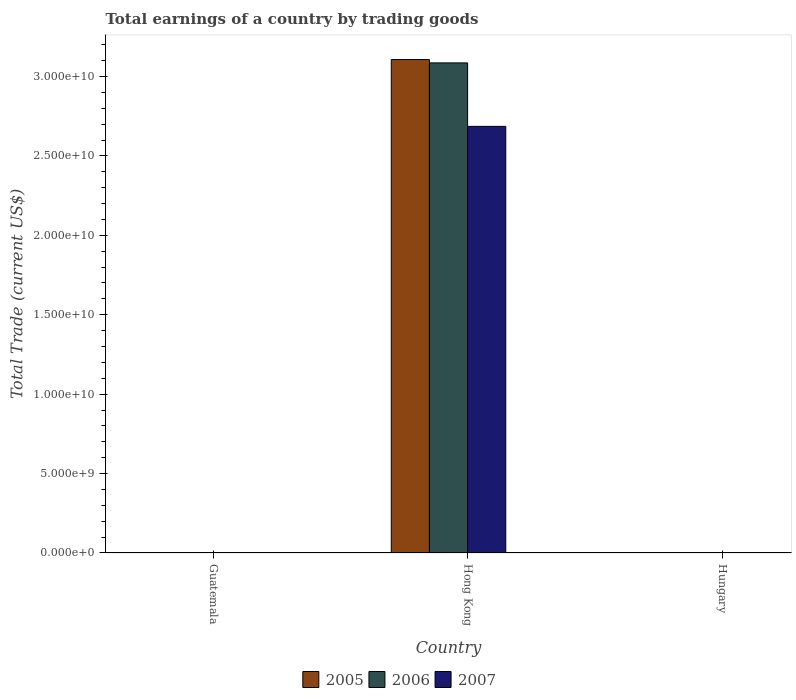How many different coloured bars are there?
Give a very brief answer. 3. Are the number of bars per tick equal to the number of legend labels?
Make the answer very short. No. Are the number of bars on each tick of the X-axis equal?
Provide a short and direct response. No. How many bars are there on the 1st tick from the right?
Your answer should be very brief. 0. What is the label of the 2nd group of bars from the left?
Keep it short and to the point. Hong Kong. What is the total earnings in 2007 in Hong Kong?
Keep it short and to the point. 2.69e+1. Across all countries, what is the maximum total earnings in 2006?
Ensure brevity in your answer.  3.09e+1. In which country was the total earnings in 2007 maximum?
Your answer should be very brief. Hong Kong. What is the total total earnings in 2006 in the graph?
Offer a very short reply. 3.09e+1. What is the difference between the total earnings in 2005 in Guatemala and the total earnings in 2007 in Hong Kong?
Keep it short and to the point. -2.69e+1. What is the average total earnings in 2006 per country?
Keep it short and to the point. 1.03e+1. What is the difference between the total earnings of/in 2005 and total earnings of/in 2006 in Hong Kong?
Provide a short and direct response. 2.11e+08. In how many countries, is the total earnings in 2006 greater than 21000000000 US$?
Make the answer very short. 1. What is the difference between the highest and the lowest total earnings in 2005?
Offer a very short reply. 3.11e+1. In how many countries, is the total earnings in 2005 greater than the average total earnings in 2005 taken over all countries?
Keep it short and to the point. 1. Is it the case that in every country, the sum of the total earnings in 2005 and total earnings in 2007 is greater than the total earnings in 2006?
Provide a succinct answer. No. How many countries are there in the graph?
Offer a very short reply. 3. Are the values on the major ticks of Y-axis written in scientific E-notation?
Your answer should be compact. Yes. Where does the legend appear in the graph?
Your answer should be compact. Bottom center. How many legend labels are there?
Provide a short and direct response. 3. What is the title of the graph?
Ensure brevity in your answer.  Total earnings of a country by trading goods. Does "2007" appear as one of the legend labels in the graph?
Your answer should be compact. Yes. What is the label or title of the Y-axis?
Give a very brief answer. Total Trade (current US$). What is the Total Trade (current US$) of 2005 in Guatemala?
Your answer should be very brief. 0. What is the Total Trade (current US$) in 2006 in Guatemala?
Your answer should be compact. 0. What is the Total Trade (current US$) in 2005 in Hong Kong?
Offer a terse response. 3.11e+1. What is the Total Trade (current US$) in 2006 in Hong Kong?
Provide a succinct answer. 3.09e+1. What is the Total Trade (current US$) of 2007 in Hong Kong?
Provide a succinct answer. 2.69e+1. What is the Total Trade (current US$) of 2005 in Hungary?
Make the answer very short. 0. What is the Total Trade (current US$) of 2007 in Hungary?
Your answer should be very brief. 0. Across all countries, what is the maximum Total Trade (current US$) in 2005?
Make the answer very short. 3.11e+1. Across all countries, what is the maximum Total Trade (current US$) of 2006?
Offer a very short reply. 3.09e+1. Across all countries, what is the maximum Total Trade (current US$) in 2007?
Make the answer very short. 2.69e+1. Across all countries, what is the minimum Total Trade (current US$) in 2005?
Offer a very short reply. 0. Across all countries, what is the minimum Total Trade (current US$) in 2006?
Offer a terse response. 0. Across all countries, what is the minimum Total Trade (current US$) of 2007?
Offer a terse response. 0. What is the total Total Trade (current US$) of 2005 in the graph?
Your response must be concise. 3.11e+1. What is the total Total Trade (current US$) of 2006 in the graph?
Give a very brief answer. 3.09e+1. What is the total Total Trade (current US$) of 2007 in the graph?
Your answer should be compact. 2.69e+1. What is the average Total Trade (current US$) of 2005 per country?
Your answer should be very brief. 1.04e+1. What is the average Total Trade (current US$) of 2006 per country?
Provide a succinct answer. 1.03e+1. What is the average Total Trade (current US$) in 2007 per country?
Your response must be concise. 8.95e+09. What is the difference between the Total Trade (current US$) of 2005 and Total Trade (current US$) of 2006 in Hong Kong?
Your answer should be very brief. 2.11e+08. What is the difference between the Total Trade (current US$) in 2005 and Total Trade (current US$) in 2007 in Hong Kong?
Give a very brief answer. 4.21e+09. What is the difference between the Total Trade (current US$) in 2006 and Total Trade (current US$) in 2007 in Hong Kong?
Provide a succinct answer. 4.00e+09. What is the difference between the highest and the lowest Total Trade (current US$) in 2005?
Provide a succinct answer. 3.11e+1. What is the difference between the highest and the lowest Total Trade (current US$) of 2006?
Offer a very short reply. 3.09e+1. What is the difference between the highest and the lowest Total Trade (current US$) in 2007?
Offer a terse response. 2.69e+1. 